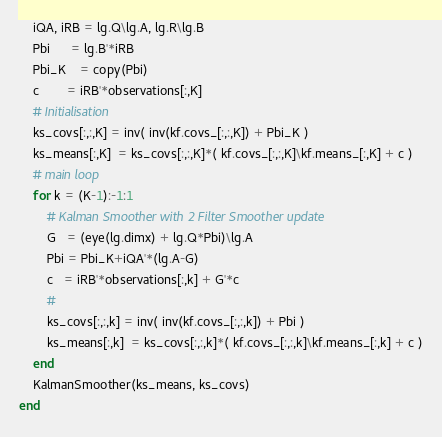<code> <loc_0><loc_0><loc_500><loc_500><_Julia_>    iQA, iRB = lg.Q\lg.A, lg.R\lg.B
    Pbi      = lg.B'*iRB
    Pbi_K    = copy(Pbi)
    c        = iRB'*observations[:,K]
    # Initialisation
    ks_covs[:,:,K] = inv( inv(kf.covs_[:,:,K]) + Pbi_K )
    ks_means[:,K]  = ks_covs[:,:,K]*( kf.covs_[:,:,K]\kf.means_[:,K] + c )
    # main loop
    for k = (K-1):-1:1
        # Kalman Smoother with 2 Filter Smoother update
        G   = (eye(lg.dimx) + lg.Q*Pbi)\lg.A
        Pbi = Pbi_K+iQA'*(lg.A-G)
        c   = iRB'*observations[:,k] + G'*c
        #
        ks_covs[:,:,k] = inv( inv(kf.covs_[:,:,k]) + Pbi )
        ks_means[:,k]  = ks_covs[:,:,k]*( kf.covs_[:,:,k]\kf.means_[:,k] + c )
    end
    KalmanSmoother(ks_means, ks_covs)
end
</code> 